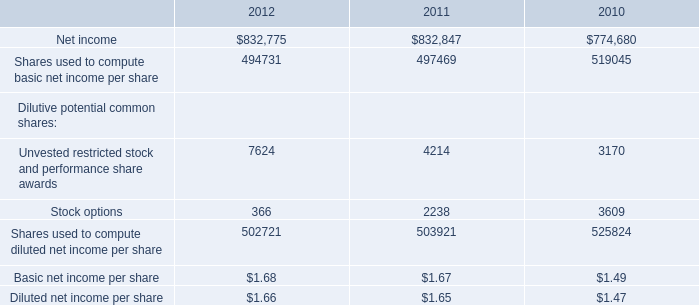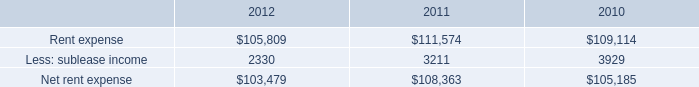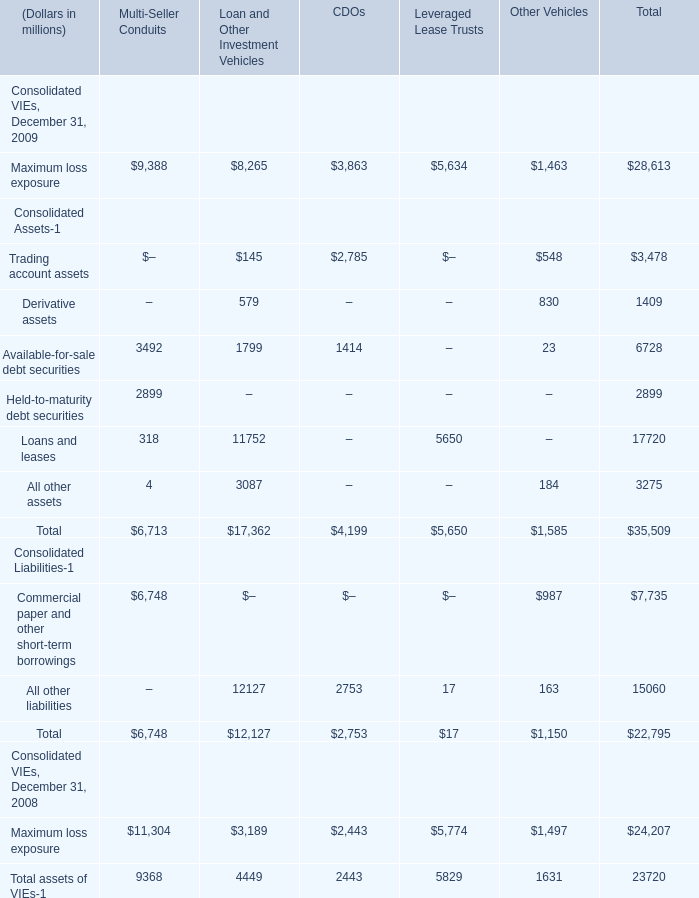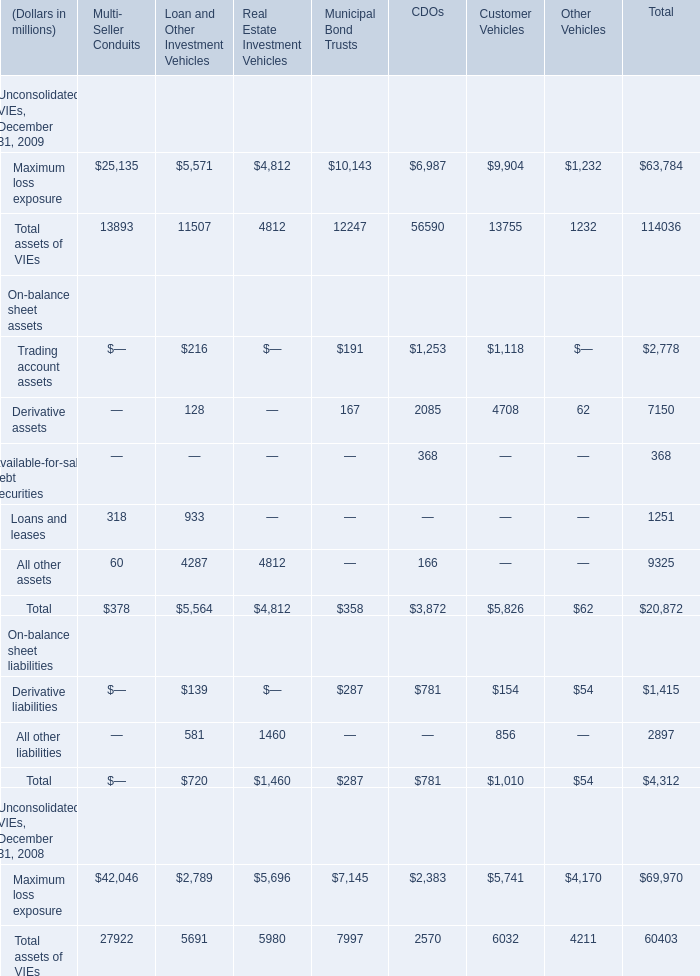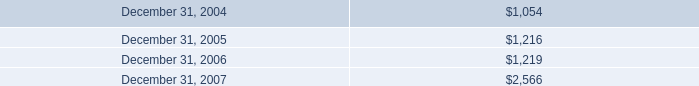Does Maximum loss exposure keeps increasing each year between 2008 and 2009? 
Answer: yes. 